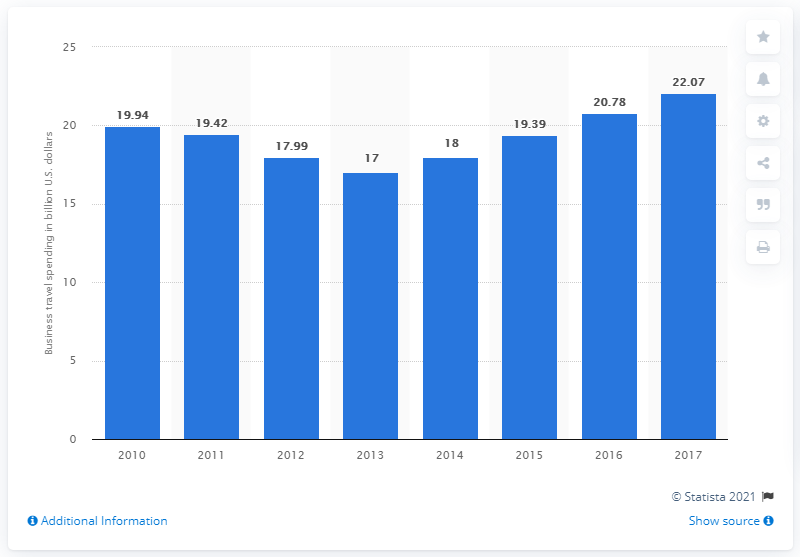Indicate a few pertinent items in this graphic. In 2017, Spain's business travel spending amounted to 22.07 million. 